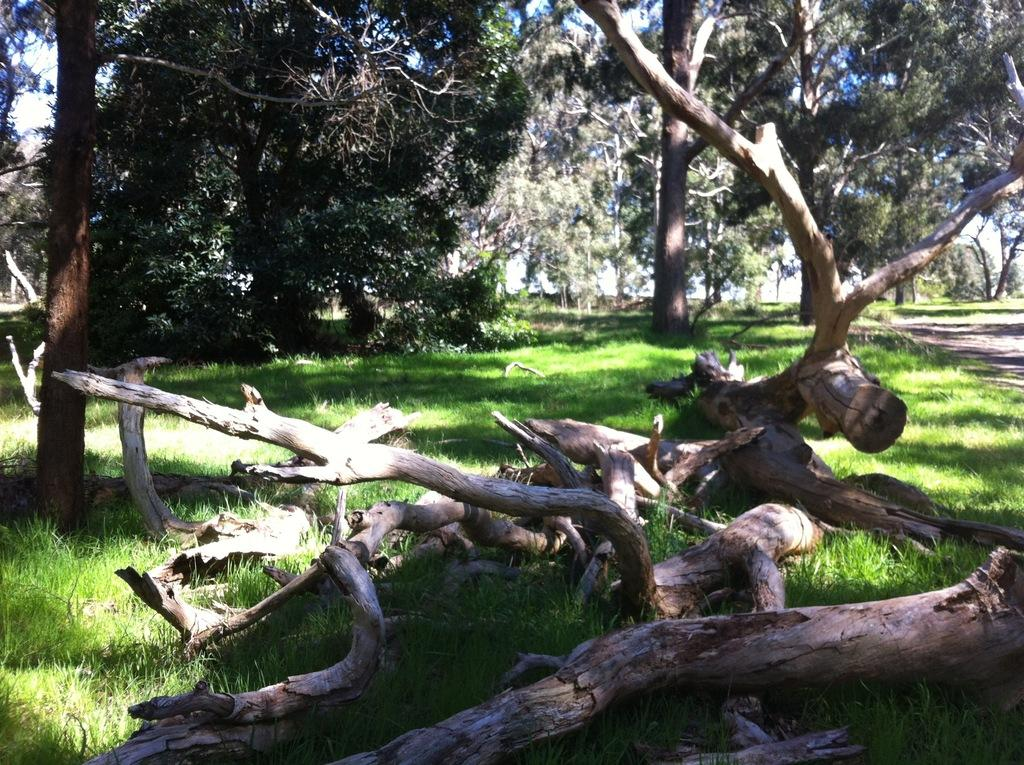What type of material are the logs made of in the image? The wooden logs in the image are made of wood. Where are the wooden logs located in the image? The wooden logs are on the grass surface in the image. What can be seen in the background of the image? There are trees around the wooden logs in the image. What type of shoes can be seen on the wooden logs in the image? There are no shoes present on the wooden logs in the image. Can you describe the face of the frog sitting on the grass in the image? There is no frog present in the image; it only features wooden logs and trees. 